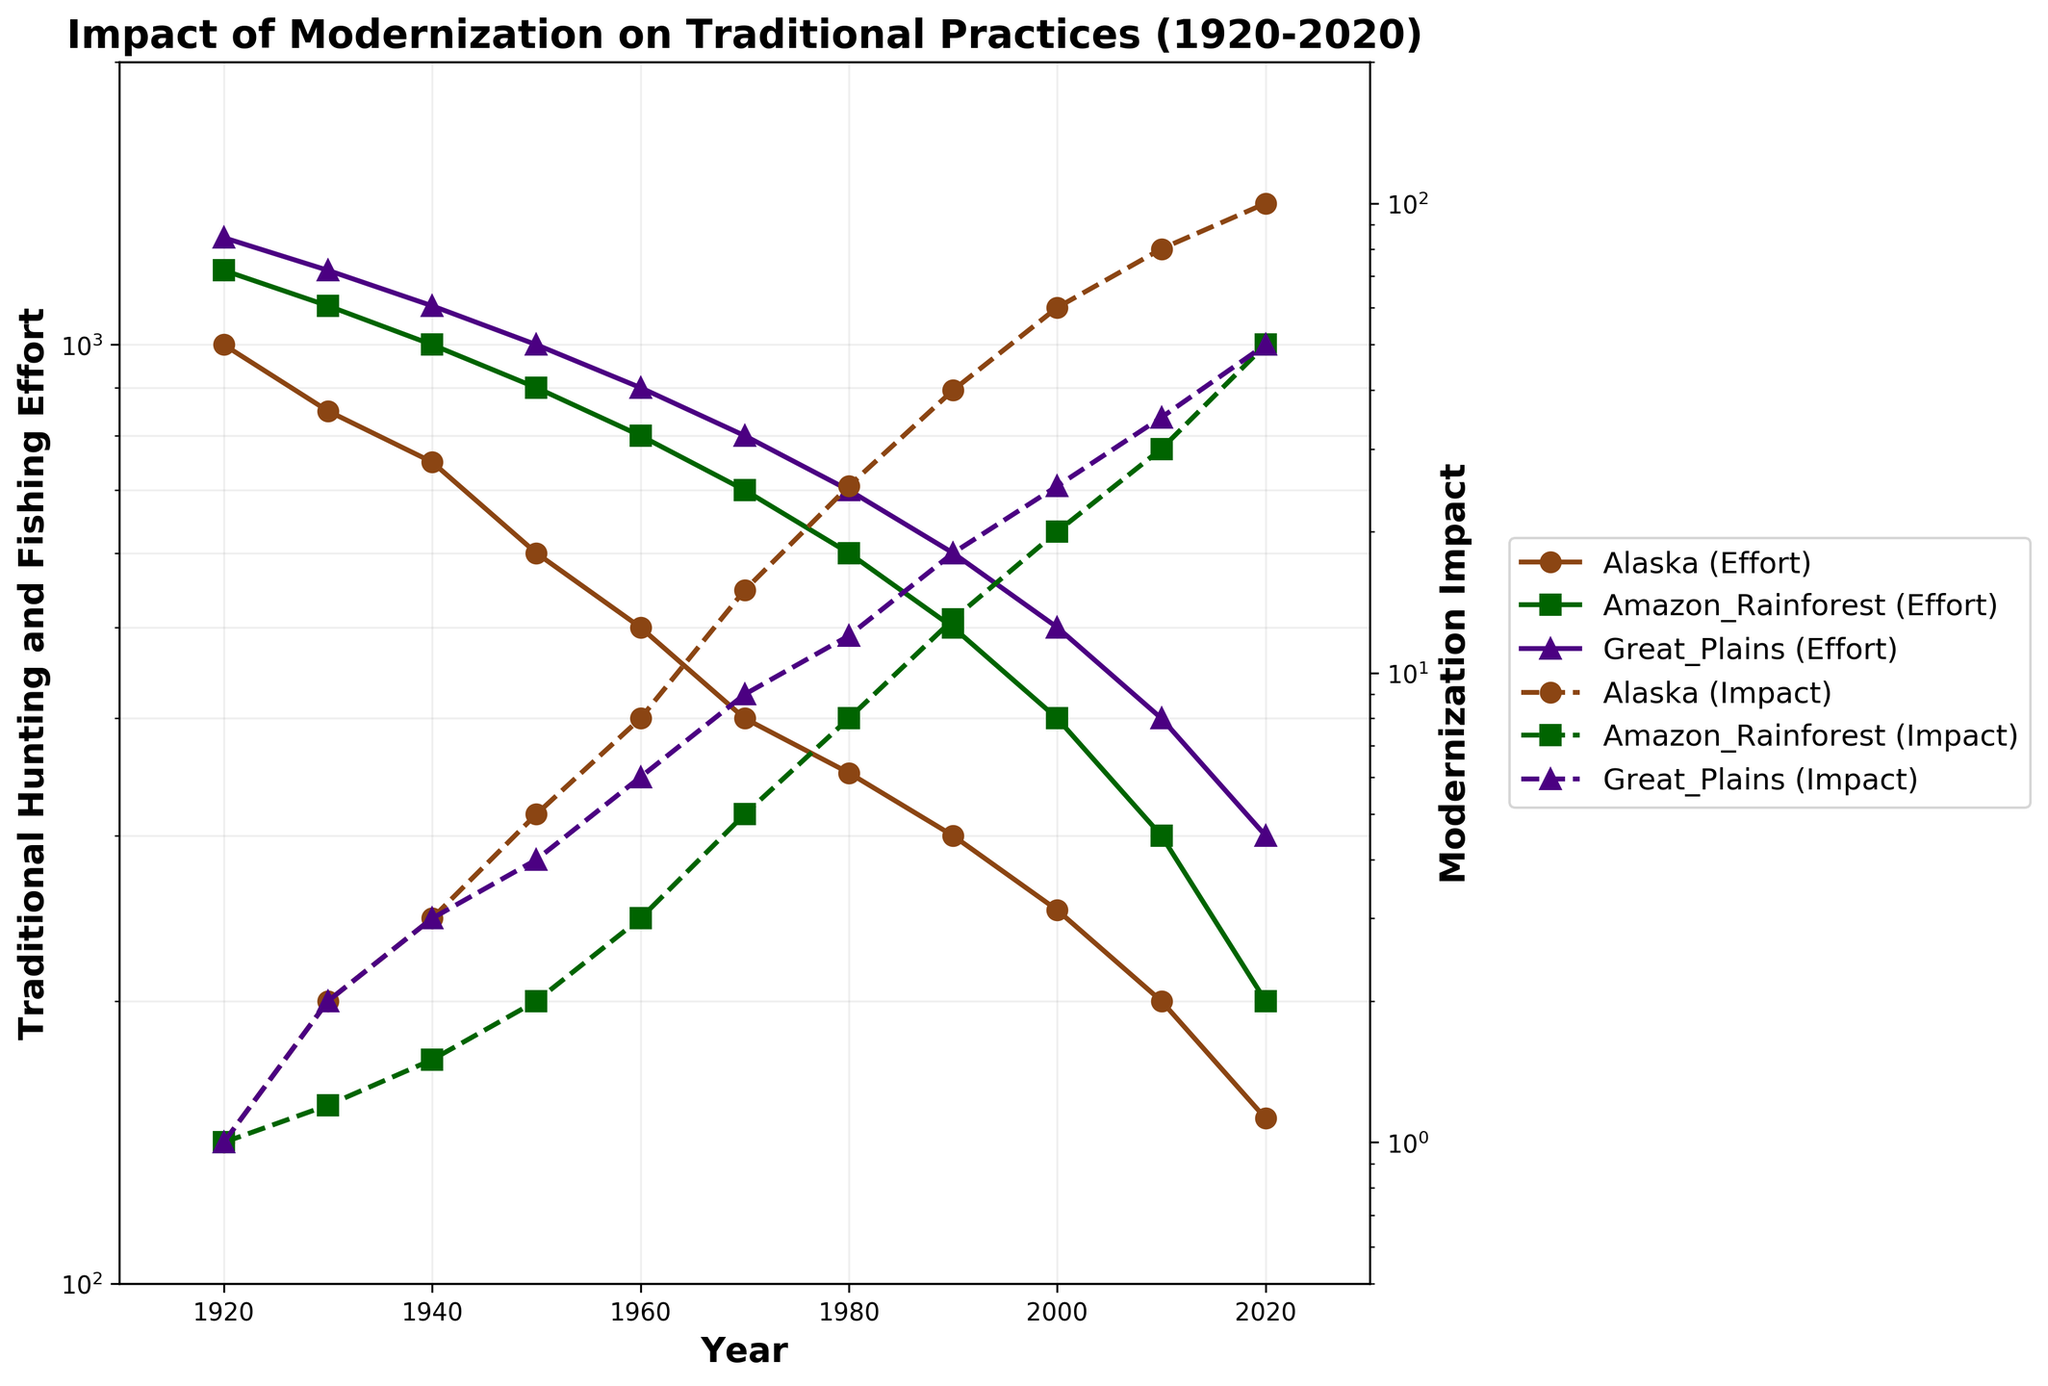What is the title of the figure? The title of the figure is located at the top and provides an overview of the content. Here, it reads "Impact of Modernization on Traditional Practices (1920-2020)".
Answer: Impact of Modernization on Traditional Practices (1920-2020) Which location had the highest traditional hunting and fishing effort in 1920? The 1920 data points show Alaska with 1000, Amazon Rainforest with 1200, and Great Plains with 1300. The Great Plains has the highest effort.
Answer: Great Plains Between 1930 and 1940, how did the modernization impact change for Alaska? Look at the dashed line representing modernization impact for Alaska between 1930 (impact of 2) and 1940 (impact of 3). The difference is 3 - 2 = 1.
Answer: Increased by 1 Which location shows the steepest decline in traditional hunting and fishing effort over the century? By observing the solid lines on the plot, Alaska’s effort drops from 1000 to 150, Amazon Rainforest from 1200 to 200, and Great Plains from 1300 to 300. The steepest decline is for Alaska.
Answer: Alaska What is the pattern of modernization impact in the Amazon Rainforest from 1920 to 2020? Examine the dashed line for Amazon Rainforest. Starting at 1 in 1920, the impact rises gradually until 1950, then increases sharply to reach 50 by 2020.
Answer: Gradually increases, then sharply increases In 2020, what is the difference between the traditional hunting and fishing effort in the Amazon Rainforest and Alaska? The 2020 data points for traditional effort show 200 for the Amazon Rainforest and 150 for Alaska. The difference is 200 - 150 = 50.
Answer: 50 At which year did the modernization impact in the Great Plains reach 25? Follow the dashed line for Great Plains. The impact reaches 25 in the year 2000.
Answer: 2000 Compare the trend of traditional hunting and fishing effort in the Amazon Rainforest and the Great Plains from 1960 to 2020. Between 1960 and 2020, both Amazon Rainforest and Great Plains exhibit a decline in traditional effort. However, Amazon Rainforest has a sharper drop, from 800 to 200, while Great Plains decreases from 900 to 300.
Answer: Both decline, Amazon Rainforest drops more sharply For which location does the modernization impact increase the most between 1970 and 1980? Look at the dashed lines between 1970 and 1980. Alaska’s impact increases from 15 to 25 (10 points), Amazon Rainforest from 5 to 8 (3 points), and Great Plains from 9 to 12 (3 points). Alaska has the largest increase.
Answer: Alaska 